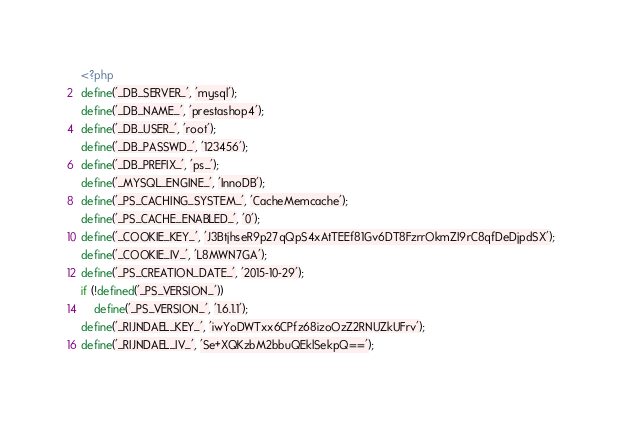Convert code to text. <code><loc_0><loc_0><loc_500><loc_500><_PHP_><?php
define('_DB_SERVER_', 'mysql');
define('_DB_NAME_', 'prestashop4');
define('_DB_USER_', 'root');
define('_DB_PASSWD_', '123456');
define('_DB_PREFIX_', 'ps_');
define('_MYSQL_ENGINE_', 'InnoDB');
define('_PS_CACHING_SYSTEM_', 'CacheMemcache');
define('_PS_CACHE_ENABLED_', '0');
define('_COOKIE_KEY_', 'J3BtjhseR9p27qQpS4xAtTEEf81Gv6DT8FzrrOkmZI9rC8qfDeDjpdSX');
define('_COOKIE_IV_', 'L8MWN7GA');
define('_PS_CREATION_DATE_', '2015-10-29');
if (!defined('_PS_VERSION_'))
	define('_PS_VERSION_', '1.6.1.1');
define('_RIJNDAEL_KEY_', 'iwYoDWTxx6CPfz68izoOzZ2RNUZkUFrv');
define('_RIJNDAEL_IV_', 'Se+XQKzbM2bbuQEklSekpQ==');
</code> 